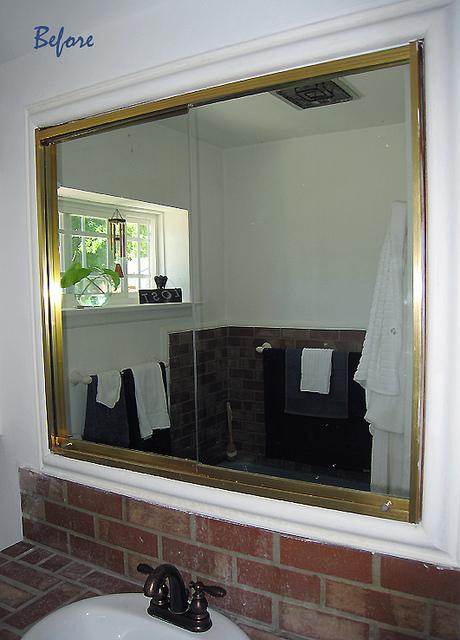What material makes up the counter?
Short answer required. Brick. Is there a mirror?
Be succinct. Yes. What color is the frame of the mirror?
Be succinct. Gold. 